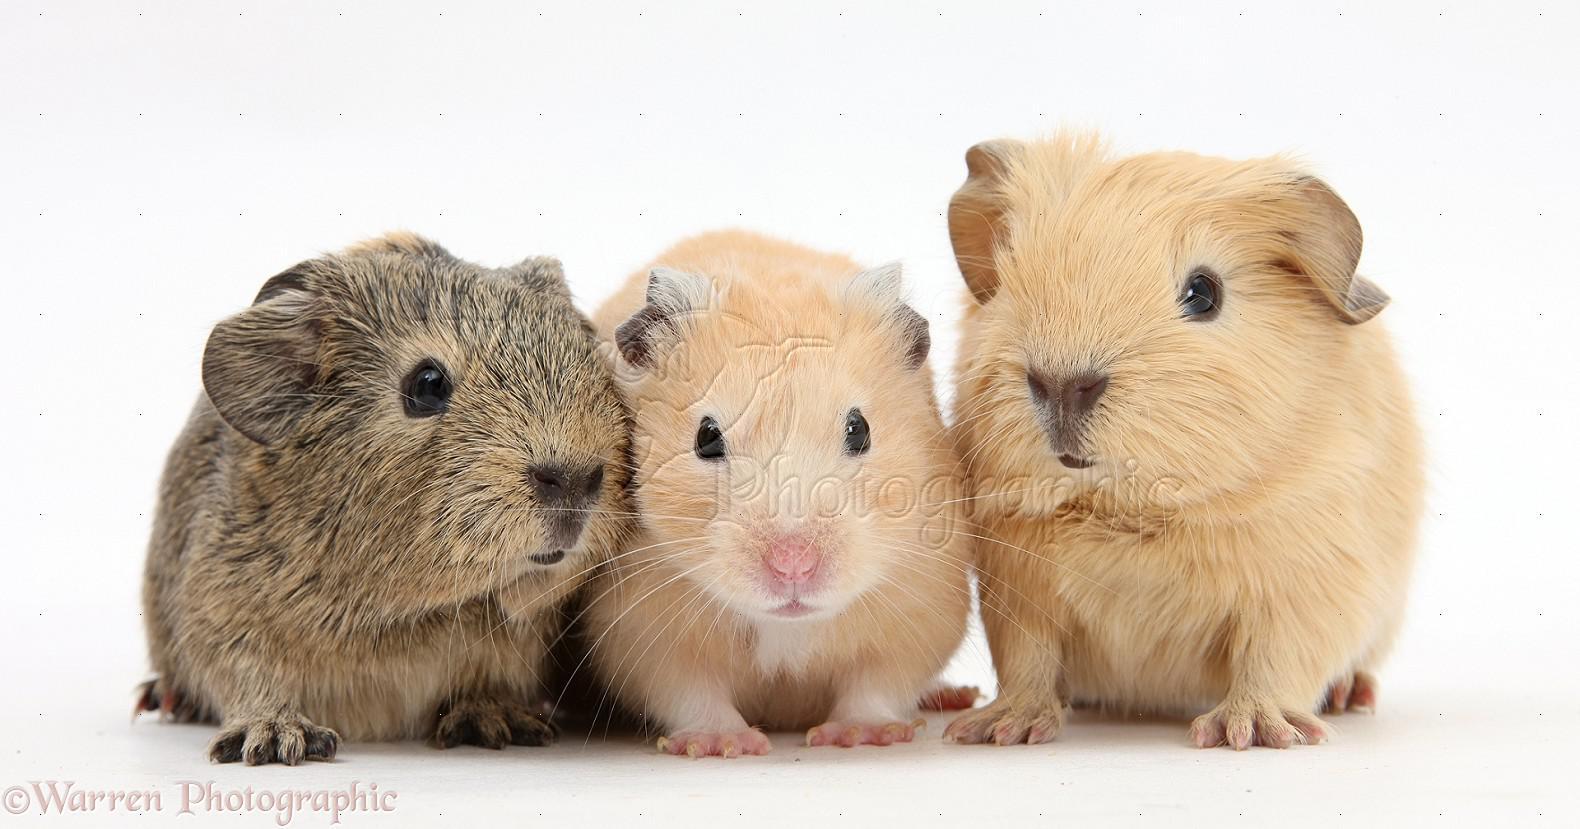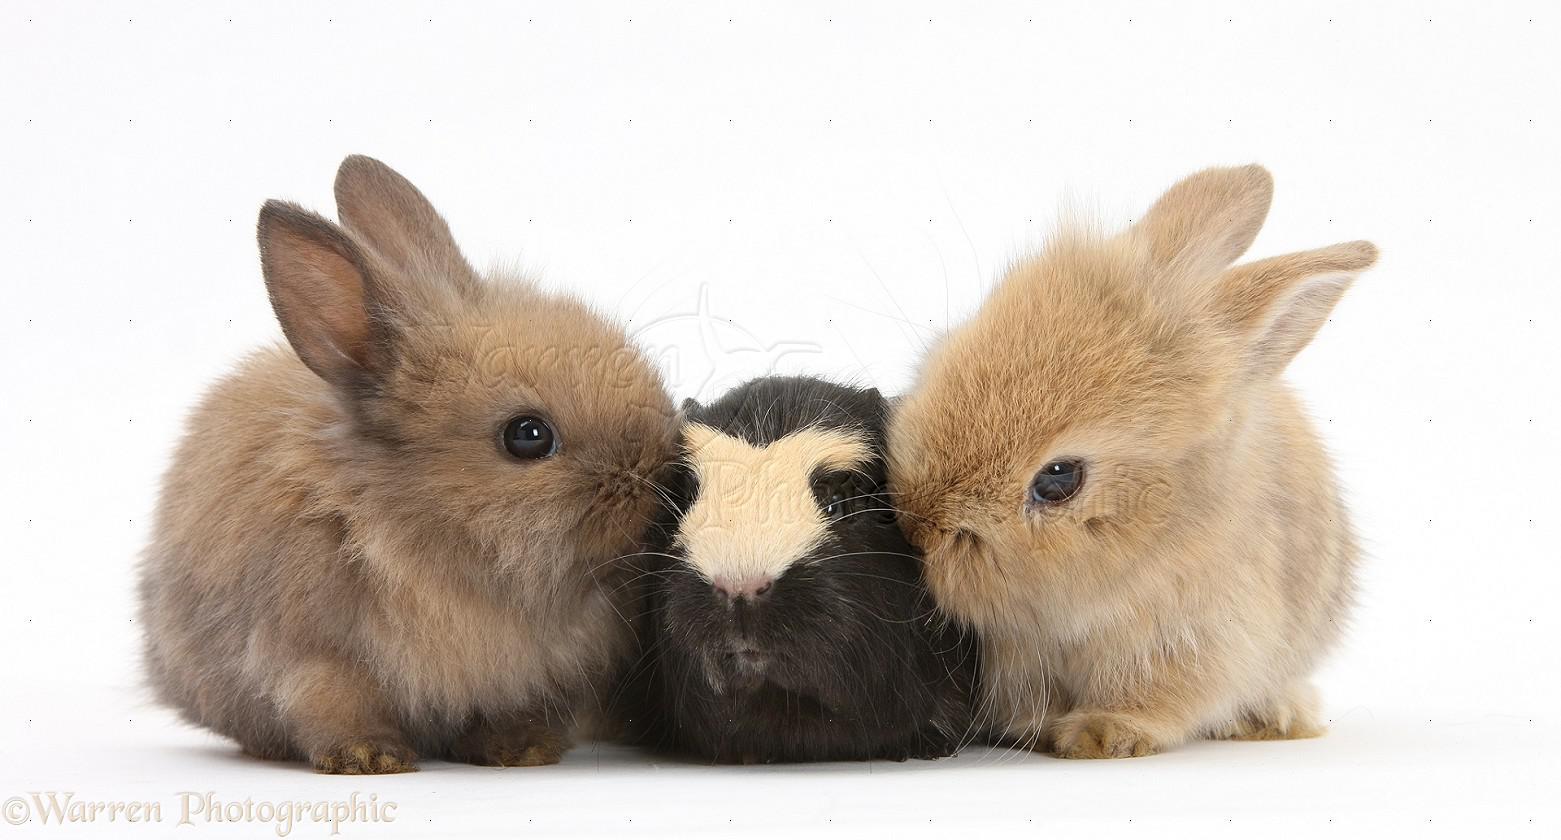The first image is the image on the left, the second image is the image on the right. Given the left and right images, does the statement "The right image contains two rabbits." hold true? Answer yes or no. Yes. The first image is the image on the left, the second image is the image on the right. Evaluate the accuracy of this statement regarding the images: "One of the images features a small animal in between two rabbits, while the other image features at least two guinea pigs.". Is it true? Answer yes or no. Yes. 